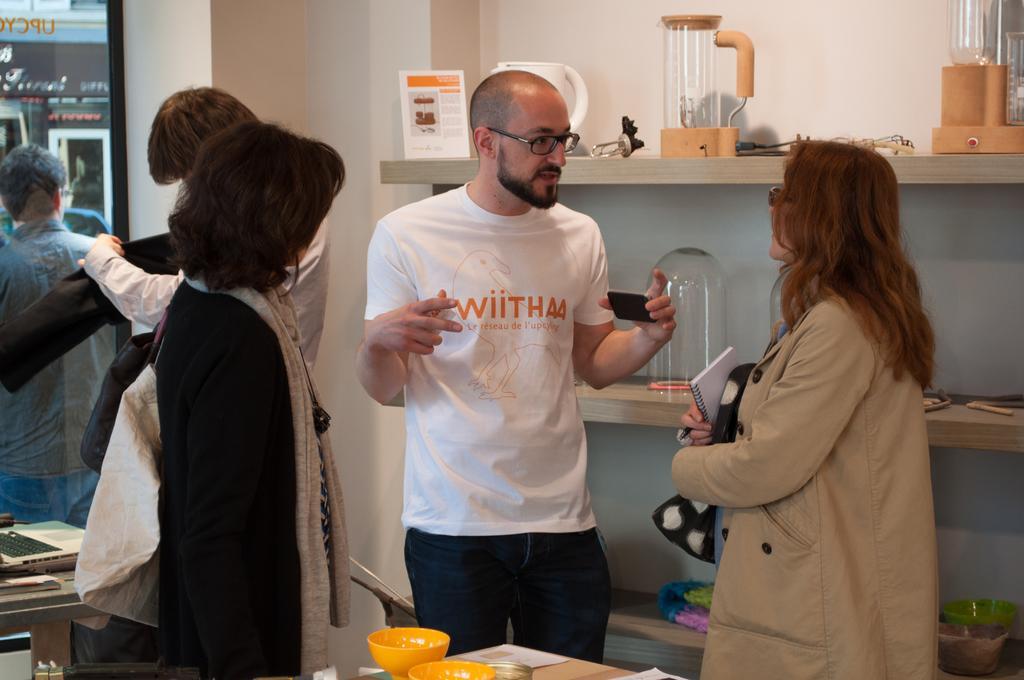Can you describe this image briefly? In this picture I can see people standing on the surface. I can see electronic device. I can see bowls on the table. I can see glass window. I can see objects on the rack. 